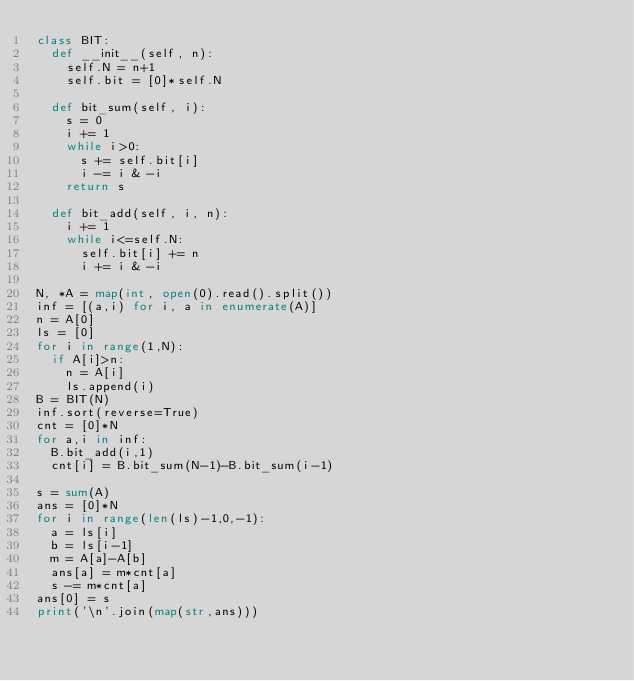Convert code to text. <code><loc_0><loc_0><loc_500><loc_500><_Python_>class BIT:
  def __init__(self, n):
    self.N = n+1
    self.bit = [0]*self.N
  
  def bit_sum(self, i):
    s = 0
    i += 1
    while i>0:
      s += self.bit[i]
      i -= i & -i
    return s

  def bit_add(self, i, n):
    i += 1
    while i<=self.N:
      self.bit[i] += n
      i += i & -i

N, *A = map(int, open(0).read().split())
inf = [(a,i) for i, a in enumerate(A)]
n = A[0]
ls = [0]
for i in range(1,N):
  if A[i]>n:
    n = A[i]
    ls.append(i)
B = BIT(N)
inf.sort(reverse=True)
cnt = [0]*N
for a,i in inf:
  B.bit_add(i,1)
  cnt[i] = B.bit_sum(N-1)-B.bit_sum(i-1)

s = sum(A)
ans = [0]*N
for i in range(len(ls)-1,0,-1):
  a = ls[i]
  b = ls[i-1]
  m = A[a]-A[b]
  ans[a] = m*cnt[a]
  s -= m*cnt[a]
ans[0] = s
print('\n'.join(map(str,ans)))</code> 